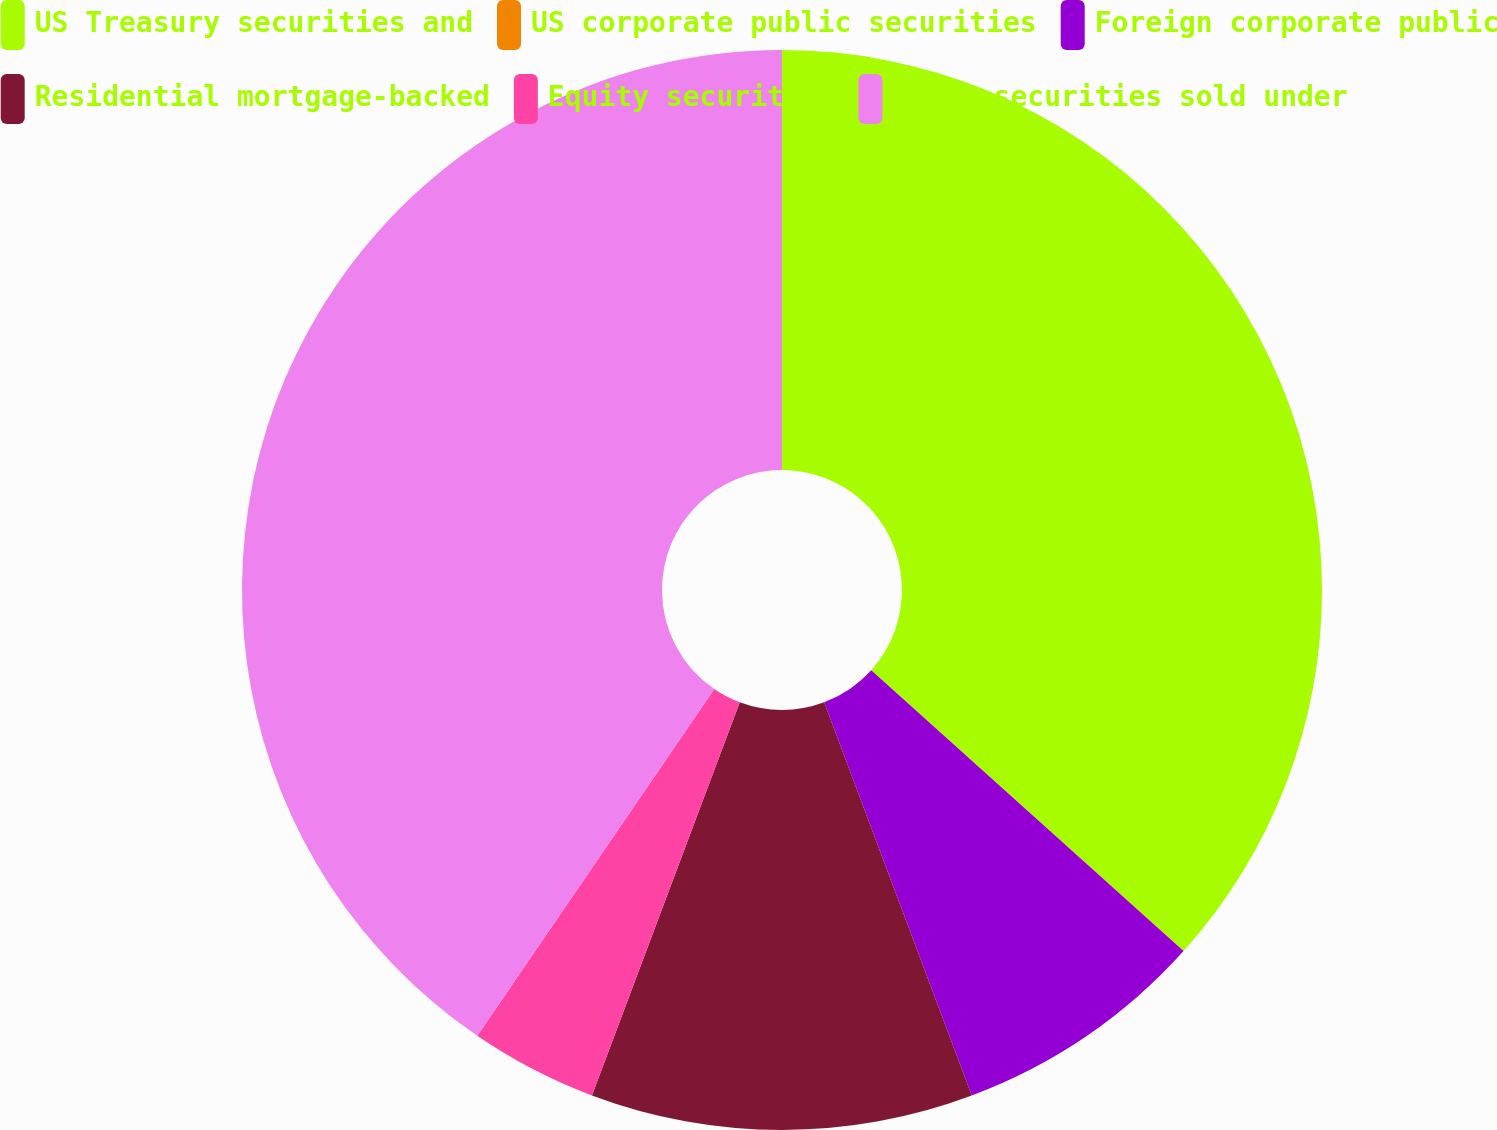<chart> <loc_0><loc_0><loc_500><loc_500><pie_chart><fcel>US Treasury securities and<fcel>US corporate public securities<fcel>Foreign corporate public<fcel>Residential mortgage-backed<fcel>Equity securities<fcel>Total securities sold under<nl><fcel>36.65%<fcel>0.01%<fcel>7.63%<fcel>11.44%<fcel>3.82%<fcel>40.46%<nl></chart> 